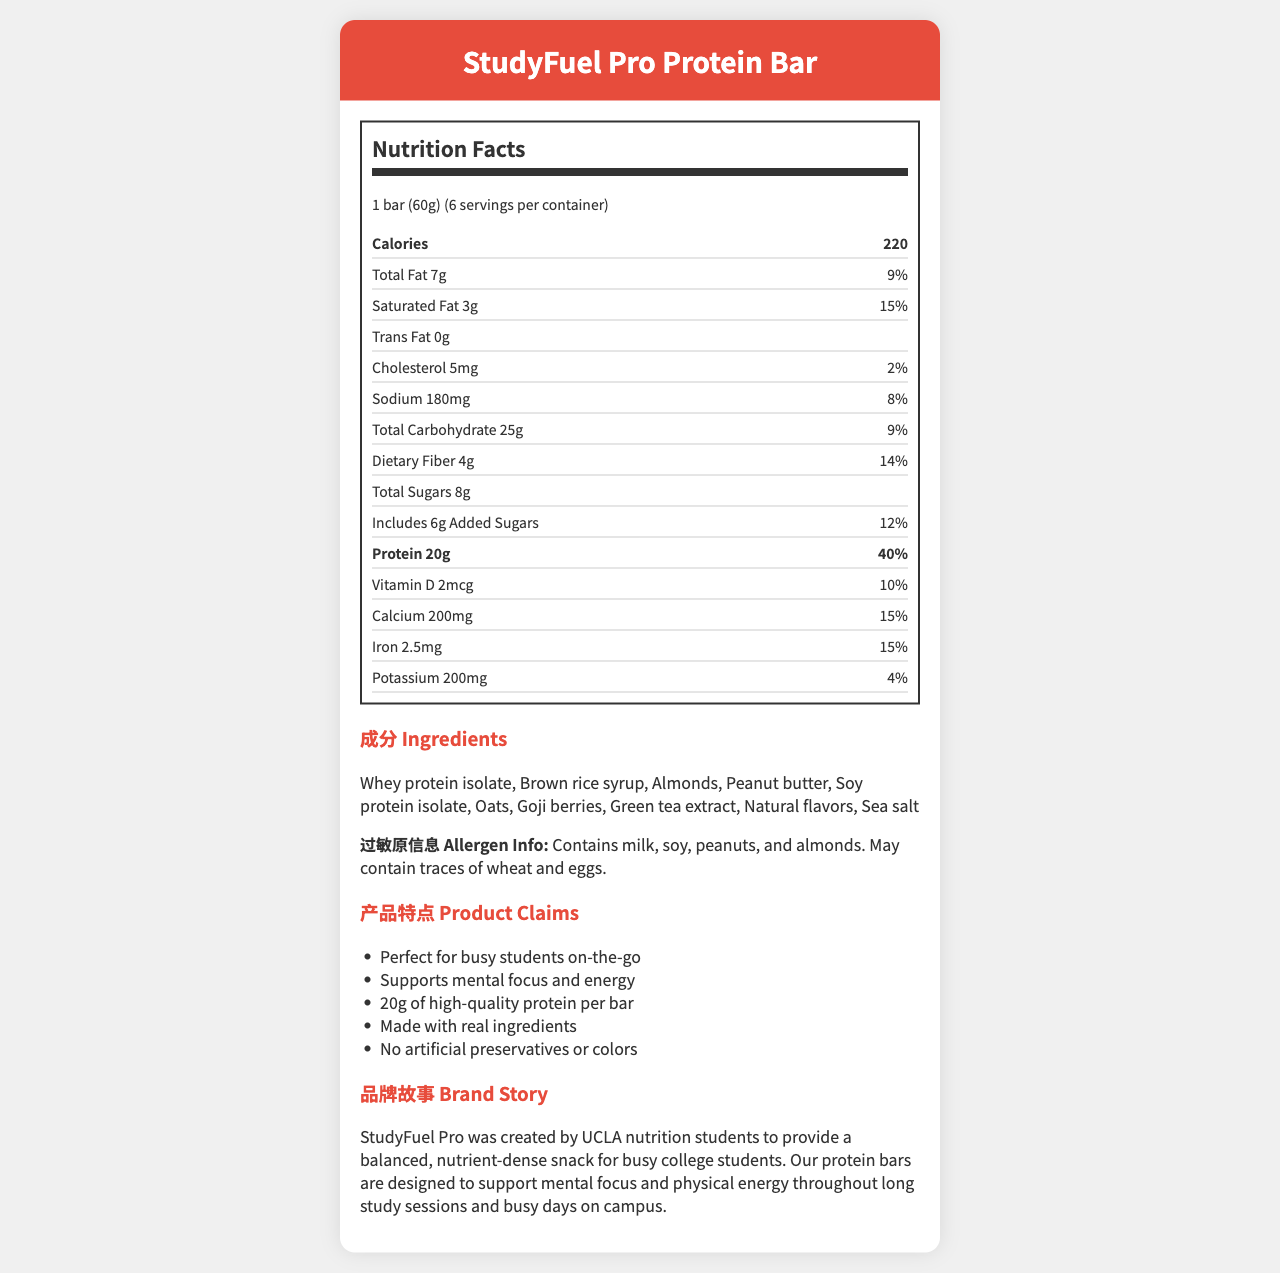what is the serving size for the StudyFuel Pro Protein Bar? The serving size is mentioned at the top of the Nutrition Facts label as "1 bar (60g)".
Answer: 1 bar (60g) how many servings are there per container? "6 servings per container" is mentioned just below the serving size on the Nutrition Facts label.
Answer: 6 what is the amount of cholesterol per serving? The amount of cholesterol is listed under the "Cholesterol" item in the Nutrition Facts label as "5mg".
Answer: 5mg how much protein does one bar of the StudyFuel Pro Protein Bar contain? The amount of protein per serving is listed as "20g" in the Nutrition Facts section.
Answer: 20g what are the main ingredients in the StudyFuel Pro Protein Bar? The main ingredients are listed in the "Ingredients" section.
Answer: Whey protein isolate, Brown rice syrup, Almonds, Peanut butter, Soy protein isolate, Oats, Goji berries, Green tea extract, Natural flavors, Sea salt what percentage of the daily value for saturated fat does one bar provide? The percent daily value for saturated fat is listed as "15%" in the Nutrition Facts label.
Answer: 15% how many calories are in one serving of the StudyFuel Pro Protein Bar? The calorie content per serving is clearly marked as "220" next to the Calories label.
Answer: 220 what marketing claims are made about the StudyFuel Pro Protein Bar? These claims are listed under the "产品特点 Product Claims" section.
Answer: Perfect for busy students on-the-go, Supports mental focus and energy, 20g of high-quality protein per bar, Made with real ingredients, No artificial preservatives or colors which of these is NOT listed as a marketing claim for the StudyFuel Pro Protein Bar? A. Supports mental focus and energy B. No artificial preservatives or colors C. Provides a full meal replacement D. Made with real ingredients Option C "Provides a full meal replacement" is not listed under the marketing claims.
Answer: C which of the following allergens are present in the StudyFuel Pro Protein Bar? A. Soy B. Almonds C. Eggs D. Peanuts The allergen info lists milk, soy, peanuts, and almonds. Eggs may be present in the trace amount, hence is not a prominent allergen listed.
Answer: C does the StudyFuel Pro Protein Bar contain any trans fat? The label shows "Trans Fat 0g" indicating there are no trans fats.
Answer: No summarize the main idea of the StudyFuel Pro Protein Bar document. The document provides a detailed overview of the product, including its nutrition facts, ingredients, marketing claims, and brand story targeted at busy students.
Answer: The StudyFuel Pro Protein Bar is designed for busy students, offering 20g of high-quality protein per bar, along with essential vitamins and minerals, while being made with real ingredients and no artificial preservatives or colors. The bar supports mental focus and physical energy, and the brand was created by UCLA nutrition students. It contains several allergens, including milk, soy, peanuts, and almonds. what is the main source of protein in the StudyFuel Pro Protein Bar? The document lists two possible sources of protein: whey protein isolate and soy protein isolate, but it does not specify which is the main source.
Answer: Cannot be determined 